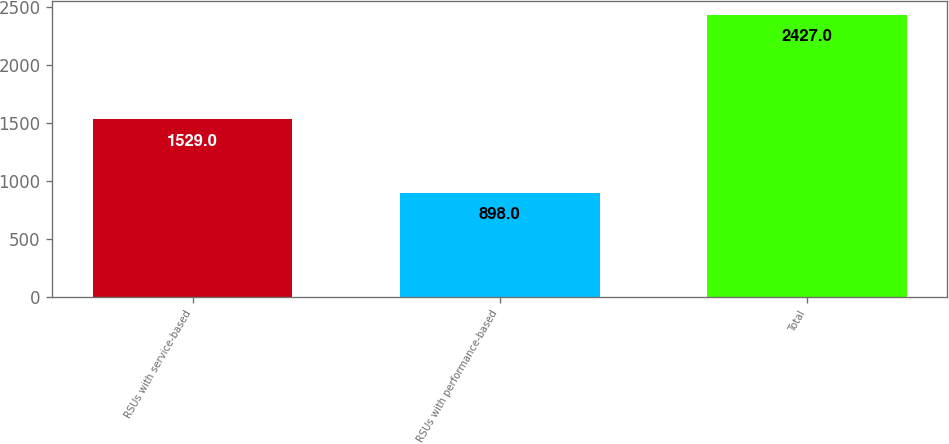Convert chart. <chart><loc_0><loc_0><loc_500><loc_500><bar_chart><fcel>RSUs with service-based<fcel>RSUs with performance-based<fcel>Total<nl><fcel>1529<fcel>898<fcel>2427<nl></chart> 